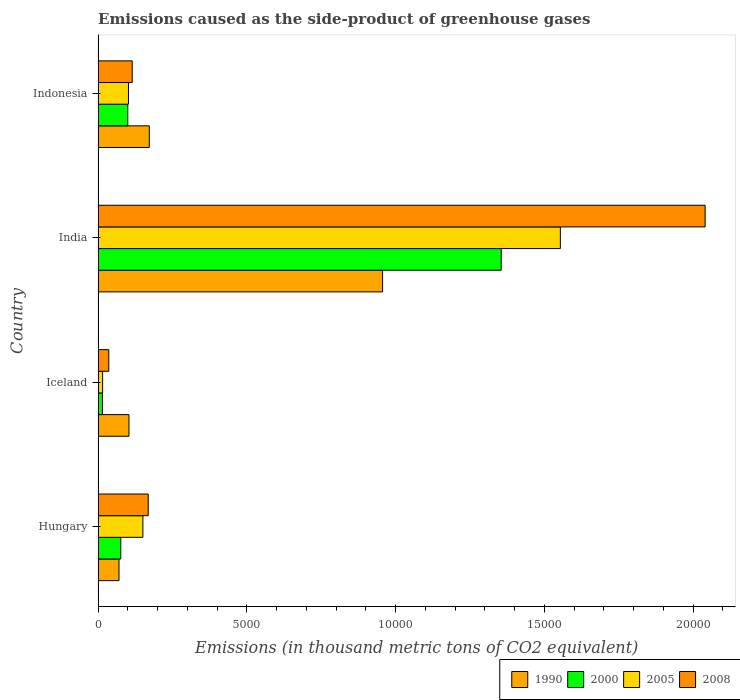Are the number of bars on each tick of the Y-axis equal?
Your answer should be compact. Yes. How many bars are there on the 1st tick from the top?
Ensure brevity in your answer.  4. What is the label of the 2nd group of bars from the top?
Offer a terse response. India. What is the emissions caused as the side-product of greenhouse gases in 1990 in Hungary?
Your answer should be compact. 702. Across all countries, what is the maximum emissions caused as the side-product of greenhouse gases in 1990?
Offer a very short reply. 9563.6. Across all countries, what is the minimum emissions caused as the side-product of greenhouse gases in 2008?
Your answer should be very brief. 358.5. In which country was the emissions caused as the side-product of greenhouse gases in 1990 minimum?
Give a very brief answer. Hungary. What is the total emissions caused as the side-product of greenhouse gases in 2000 in the graph?
Provide a short and direct response. 1.55e+04. What is the difference between the emissions caused as the side-product of greenhouse gases in 1990 in Hungary and that in Indonesia?
Your response must be concise. -1018.7. What is the difference between the emissions caused as the side-product of greenhouse gases in 1990 in Iceland and the emissions caused as the side-product of greenhouse gases in 2008 in Indonesia?
Ensure brevity in your answer.  -109.1. What is the average emissions caused as the side-product of greenhouse gases in 1990 per country?
Give a very brief answer. 3255.8. What is the difference between the emissions caused as the side-product of greenhouse gases in 2000 and emissions caused as the side-product of greenhouse gases in 1990 in Iceland?
Provide a succinct answer. -892.1. In how many countries, is the emissions caused as the side-product of greenhouse gases in 2005 greater than 16000 thousand metric tons?
Your answer should be very brief. 0. What is the ratio of the emissions caused as the side-product of greenhouse gases in 2005 in Hungary to that in India?
Your response must be concise. 0.1. Is the difference between the emissions caused as the side-product of greenhouse gases in 2000 in Iceland and Indonesia greater than the difference between the emissions caused as the side-product of greenhouse gases in 1990 in Iceland and Indonesia?
Give a very brief answer. No. What is the difference between the highest and the second highest emissions caused as the side-product of greenhouse gases in 2008?
Provide a succinct answer. 1.87e+04. What is the difference between the highest and the lowest emissions caused as the side-product of greenhouse gases in 2008?
Ensure brevity in your answer.  2.00e+04. Is it the case that in every country, the sum of the emissions caused as the side-product of greenhouse gases in 2000 and emissions caused as the side-product of greenhouse gases in 2008 is greater than the sum of emissions caused as the side-product of greenhouse gases in 1990 and emissions caused as the side-product of greenhouse gases in 2005?
Your response must be concise. No. What does the 1st bar from the top in India represents?
Your answer should be very brief. 2008. What does the 1st bar from the bottom in Iceland represents?
Your answer should be compact. 1990. Are all the bars in the graph horizontal?
Make the answer very short. Yes. What is the difference between two consecutive major ticks on the X-axis?
Your answer should be compact. 5000. Are the values on the major ticks of X-axis written in scientific E-notation?
Provide a succinct answer. No. Where does the legend appear in the graph?
Provide a succinct answer. Bottom right. How are the legend labels stacked?
Your answer should be compact. Horizontal. What is the title of the graph?
Provide a short and direct response. Emissions caused as the side-product of greenhouse gases. Does "1993" appear as one of the legend labels in the graph?
Provide a short and direct response. No. What is the label or title of the X-axis?
Your answer should be very brief. Emissions (in thousand metric tons of CO2 equivalent). What is the Emissions (in thousand metric tons of CO2 equivalent) of 1990 in Hungary?
Provide a short and direct response. 702. What is the Emissions (in thousand metric tons of CO2 equivalent) in 2000 in Hungary?
Provide a short and direct response. 761.9. What is the Emissions (in thousand metric tons of CO2 equivalent) of 2005 in Hungary?
Your response must be concise. 1505.1. What is the Emissions (in thousand metric tons of CO2 equivalent) of 2008 in Hungary?
Your response must be concise. 1684.5. What is the Emissions (in thousand metric tons of CO2 equivalent) of 1990 in Iceland?
Your response must be concise. 1036.9. What is the Emissions (in thousand metric tons of CO2 equivalent) of 2000 in Iceland?
Give a very brief answer. 144.8. What is the Emissions (in thousand metric tons of CO2 equivalent) of 2005 in Iceland?
Make the answer very short. 151.7. What is the Emissions (in thousand metric tons of CO2 equivalent) in 2008 in Iceland?
Keep it short and to the point. 358.5. What is the Emissions (in thousand metric tons of CO2 equivalent) of 1990 in India?
Offer a very short reply. 9563.6. What is the Emissions (in thousand metric tons of CO2 equivalent) in 2000 in India?
Your answer should be compact. 1.36e+04. What is the Emissions (in thousand metric tons of CO2 equivalent) of 2005 in India?
Make the answer very short. 1.55e+04. What is the Emissions (in thousand metric tons of CO2 equivalent) in 2008 in India?
Offer a terse response. 2.04e+04. What is the Emissions (in thousand metric tons of CO2 equivalent) of 1990 in Indonesia?
Ensure brevity in your answer.  1720.7. What is the Emissions (in thousand metric tons of CO2 equivalent) of 2000 in Indonesia?
Your answer should be very brief. 997.4. What is the Emissions (in thousand metric tons of CO2 equivalent) in 2005 in Indonesia?
Your response must be concise. 1020.5. What is the Emissions (in thousand metric tons of CO2 equivalent) in 2008 in Indonesia?
Give a very brief answer. 1146. Across all countries, what is the maximum Emissions (in thousand metric tons of CO2 equivalent) in 1990?
Offer a terse response. 9563.6. Across all countries, what is the maximum Emissions (in thousand metric tons of CO2 equivalent) of 2000?
Offer a very short reply. 1.36e+04. Across all countries, what is the maximum Emissions (in thousand metric tons of CO2 equivalent) in 2005?
Keep it short and to the point. 1.55e+04. Across all countries, what is the maximum Emissions (in thousand metric tons of CO2 equivalent) of 2008?
Make the answer very short. 2.04e+04. Across all countries, what is the minimum Emissions (in thousand metric tons of CO2 equivalent) in 1990?
Provide a succinct answer. 702. Across all countries, what is the minimum Emissions (in thousand metric tons of CO2 equivalent) in 2000?
Provide a short and direct response. 144.8. Across all countries, what is the minimum Emissions (in thousand metric tons of CO2 equivalent) of 2005?
Offer a very short reply. 151.7. Across all countries, what is the minimum Emissions (in thousand metric tons of CO2 equivalent) of 2008?
Provide a succinct answer. 358.5. What is the total Emissions (in thousand metric tons of CO2 equivalent) of 1990 in the graph?
Keep it short and to the point. 1.30e+04. What is the total Emissions (in thousand metric tons of CO2 equivalent) in 2000 in the graph?
Give a very brief answer. 1.55e+04. What is the total Emissions (in thousand metric tons of CO2 equivalent) in 2005 in the graph?
Offer a very short reply. 1.82e+04. What is the total Emissions (in thousand metric tons of CO2 equivalent) in 2008 in the graph?
Provide a short and direct response. 2.36e+04. What is the difference between the Emissions (in thousand metric tons of CO2 equivalent) in 1990 in Hungary and that in Iceland?
Ensure brevity in your answer.  -334.9. What is the difference between the Emissions (in thousand metric tons of CO2 equivalent) in 2000 in Hungary and that in Iceland?
Provide a succinct answer. 617.1. What is the difference between the Emissions (in thousand metric tons of CO2 equivalent) in 2005 in Hungary and that in Iceland?
Your response must be concise. 1353.4. What is the difference between the Emissions (in thousand metric tons of CO2 equivalent) in 2008 in Hungary and that in Iceland?
Provide a succinct answer. 1326. What is the difference between the Emissions (in thousand metric tons of CO2 equivalent) in 1990 in Hungary and that in India?
Offer a very short reply. -8861.6. What is the difference between the Emissions (in thousand metric tons of CO2 equivalent) in 2000 in Hungary and that in India?
Keep it short and to the point. -1.28e+04. What is the difference between the Emissions (in thousand metric tons of CO2 equivalent) in 2005 in Hungary and that in India?
Provide a short and direct response. -1.40e+04. What is the difference between the Emissions (in thousand metric tons of CO2 equivalent) of 2008 in Hungary and that in India?
Provide a succinct answer. -1.87e+04. What is the difference between the Emissions (in thousand metric tons of CO2 equivalent) of 1990 in Hungary and that in Indonesia?
Offer a terse response. -1018.7. What is the difference between the Emissions (in thousand metric tons of CO2 equivalent) in 2000 in Hungary and that in Indonesia?
Provide a succinct answer. -235.5. What is the difference between the Emissions (in thousand metric tons of CO2 equivalent) of 2005 in Hungary and that in Indonesia?
Offer a terse response. 484.6. What is the difference between the Emissions (in thousand metric tons of CO2 equivalent) of 2008 in Hungary and that in Indonesia?
Your answer should be compact. 538.5. What is the difference between the Emissions (in thousand metric tons of CO2 equivalent) in 1990 in Iceland and that in India?
Give a very brief answer. -8526.7. What is the difference between the Emissions (in thousand metric tons of CO2 equivalent) of 2000 in Iceland and that in India?
Give a very brief answer. -1.34e+04. What is the difference between the Emissions (in thousand metric tons of CO2 equivalent) of 2005 in Iceland and that in India?
Your response must be concise. -1.54e+04. What is the difference between the Emissions (in thousand metric tons of CO2 equivalent) of 2008 in Iceland and that in India?
Your answer should be very brief. -2.00e+04. What is the difference between the Emissions (in thousand metric tons of CO2 equivalent) in 1990 in Iceland and that in Indonesia?
Ensure brevity in your answer.  -683.8. What is the difference between the Emissions (in thousand metric tons of CO2 equivalent) of 2000 in Iceland and that in Indonesia?
Offer a terse response. -852.6. What is the difference between the Emissions (in thousand metric tons of CO2 equivalent) in 2005 in Iceland and that in Indonesia?
Provide a short and direct response. -868.8. What is the difference between the Emissions (in thousand metric tons of CO2 equivalent) of 2008 in Iceland and that in Indonesia?
Offer a very short reply. -787.5. What is the difference between the Emissions (in thousand metric tons of CO2 equivalent) in 1990 in India and that in Indonesia?
Your answer should be very brief. 7842.9. What is the difference between the Emissions (in thousand metric tons of CO2 equivalent) of 2000 in India and that in Indonesia?
Offer a very short reply. 1.26e+04. What is the difference between the Emissions (in thousand metric tons of CO2 equivalent) of 2005 in India and that in Indonesia?
Ensure brevity in your answer.  1.45e+04. What is the difference between the Emissions (in thousand metric tons of CO2 equivalent) of 2008 in India and that in Indonesia?
Ensure brevity in your answer.  1.93e+04. What is the difference between the Emissions (in thousand metric tons of CO2 equivalent) of 1990 in Hungary and the Emissions (in thousand metric tons of CO2 equivalent) of 2000 in Iceland?
Keep it short and to the point. 557.2. What is the difference between the Emissions (in thousand metric tons of CO2 equivalent) in 1990 in Hungary and the Emissions (in thousand metric tons of CO2 equivalent) in 2005 in Iceland?
Your answer should be very brief. 550.3. What is the difference between the Emissions (in thousand metric tons of CO2 equivalent) in 1990 in Hungary and the Emissions (in thousand metric tons of CO2 equivalent) in 2008 in Iceland?
Keep it short and to the point. 343.5. What is the difference between the Emissions (in thousand metric tons of CO2 equivalent) of 2000 in Hungary and the Emissions (in thousand metric tons of CO2 equivalent) of 2005 in Iceland?
Your answer should be very brief. 610.2. What is the difference between the Emissions (in thousand metric tons of CO2 equivalent) of 2000 in Hungary and the Emissions (in thousand metric tons of CO2 equivalent) of 2008 in Iceland?
Make the answer very short. 403.4. What is the difference between the Emissions (in thousand metric tons of CO2 equivalent) in 2005 in Hungary and the Emissions (in thousand metric tons of CO2 equivalent) in 2008 in Iceland?
Ensure brevity in your answer.  1146.6. What is the difference between the Emissions (in thousand metric tons of CO2 equivalent) of 1990 in Hungary and the Emissions (in thousand metric tons of CO2 equivalent) of 2000 in India?
Provide a succinct answer. -1.28e+04. What is the difference between the Emissions (in thousand metric tons of CO2 equivalent) in 1990 in Hungary and the Emissions (in thousand metric tons of CO2 equivalent) in 2005 in India?
Keep it short and to the point. -1.48e+04. What is the difference between the Emissions (in thousand metric tons of CO2 equivalent) of 1990 in Hungary and the Emissions (in thousand metric tons of CO2 equivalent) of 2008 in India?
Your response must be concise. -1.97e+04. What is the difference between the Emissions (in thousand metric tons of CO2 equivalent) of 2000 in Hungary and the Emissions (in thousand metric tons of CO2 equivalent) of 2005 in India?
Your answer should be compact. -1.48e+04. What is the difference between the Emissions (in thousand metric tons of CO2 equivalent) in 2000 in Hungary and the Emissions (in thousand metric tons of CO2 equivalent) in 2008 in India?
Your response must be concise. -1.96e+04. What is the difference between the Emissions (in thousand metric tons of CO2 equivalent) in 2005 in Hungary and the Emissions (in thousand metric tons of CO2 equivalent) in 2008 in India?
Keep it short and to the point. -1.89e+04. What is the difference between the Emissions (in thousand metric tons of CO2 equivalent) in 1990 in Hungary and the Emissions (in thousand metric tons of CO2 equivalent) in 2000 in Indonesia?
Offer a very short reply. -295.4. What is the difference between the Emissions (in thousand metric tons of CO2 equivalent) in 1990 in Hungary and the Emissions (in thousand metric tons of CO2 equivalent) in 2005 in Indonesia?
Keep it short and to the point. -318.5. What is the difference between the Emissions (in thousand metric tons of CO2 equivalent) of 1990 in Hungary and the Emissions (in thousand metric tons of CO2 equivalent) of 2008 in Indonesia?
Provide a short and direct response. -444. What is the difference between the Emissions (in thousand metric tons of CO2 equivalent) in 2000 in Hungary and the Emissions (in thousand metric tons of CO2 equivalent) in 2005 in Indonesia?
Provide a short and direct response. -258.6. What is the difference between the Emissions (in thousand metric tons of CO2 equivalent) in 2000 in Hungary and the Emissions (in thousand metric tons of CO2 equivalent) in 2008 in Indonesia?
Provide a succinct answer. -384.1. What is the difference between the Emissions (in thousand metric tons of CO2 equivalent) in 2005 in Hungary and the Emissions (in thousand metric tons of CO2 equivalent) in 2008 in Indonesia?
Make the answer very short. 359.1. What is the difference between the Emissions (in thousand metric tons of CO2 equivalent) in 1990 in Iceland and the Emissions (in thousand metric tons of CO2 equivalent) in 2000 in India?
Provide a succinct answer. -1.25e+04. What is the difference between the Emissions (in thousand metric tons of CO2 equivalent) of 1990 in Iceland and the Emissions (in thousand metric tons of CO2 equivalent) of 2005 in India?
Your answer should be very brief. -1.45e+04. What is the difference between the Emissions (in thousand metric tons of CO2 equivalent) of 1990 in Iceland and the Emissions (in thousand metric tons of CO2 equivalent) of 2008 in India?
Your answer should be very brief. -1.94e+04. What is the difference between the Emissions (in thousand metric tons of CO2 equivalent) of 2000 in Iceland and the Emissions (in thousand metric tons of CO2 equivalent) of 2005 in India?
Your answer should be very brief. -1.54e+04. What is the difference between the Emissions (in thousand metric tons of CO2 equivalent) in 2000 in Iceland and the Emissions (in thousand metric tons of CO2 equivalent) in 2008 in India?
Give a very brief answer. -2.03e+04. What is the difference between the Emissions (in thousand metric tons of CO2 equivalent) of 2005 in Iceland and the Emissions (in thousand metric tons of CO2 equivalent) of 2008 in India?
Ensure brevity in your answer.  -2.03e+04. What is the difference between the Emissions (in thousand metric tons of CO2 equivalent) in 1990 in Iceland and the Emissions (in thousand metric tons of CO2 equivalent) in 2000 in Indonesia?
Give a very brief answer. 39.5. What is the difference between the Emissions (in thousand metric tons of CO2 equivalent) in 1990 in Iceland and the Emissions (in thousand metric tons of CO2 equivalent) in 2008 in Indonesia?
Your response must be concise. -109.1. What is the difference between the Emissions (in thousand metric tons of CO2 equivalent) in 2000 in Iceland and the Emissions (in thousand metric tons of CO2 equivalent) in 2005 in Indonesia?
Your answer should be compact. -875.7. What is the difference between the Emissions (in thousand metric tons of CO2 equivalent) of 2000 in Iceland and the Emissions (in thousand metric tons of CO2 equivalent) of 2008 in Indonesia?
Your answer should be very brief. -1001.2. What is the difference between the Emissions (in thousand metric tons of CO2 equivalent) of 2005 in Iceland and the Emissions (in thousand metric tons of CO2 equivalent) of 2008 in Indonesia?
Keep it short and to the point. -994.3. What is the difference between the Emissions (in thousand metric tons of CO2 equivalent) in 1990 in India and the Emissions (in thousand metric tons of CO2 equivalent) in 2000 in Indonesia?
Give a very brief answer. 8566.2. What is the difference between the Emissions (in thousand metric tons of CO2 equivalent) of 1990 in India and the Emissions (in thousand metric tons of CO2 equivalent) of 2005 in Indonesia?
Keep it short and to the point. 8543.1. What is the difference between the Emissions (in thousand metric tons of CO2 equivalent) of 1990 in India and the Emissions (in thousand metric tons of CO2 equivalent) of 2008 in Indonesia?
Your response must be concise. 8417.6. What is the difference between the Emissions (in thousand metric tons of CO2 equivalent) in 2000 in India and the Emissions (in thousand metric tons of CO2 equivalent) in 2005 in Indonesia?
Provide a succinct answer. 1.25e+04. What is the difference between the Emissions (in thousand metric tons of CO2 equivalent) of 2000 in India and the Emissions (in thousand metric tons of CO2 equivalent) of 2008 in Indonesia?
Give a very brief answer. 1.24e+04. What is the difference between the Emissions (in thousand metric tons of CO2 equivalent) in 2005 in India and the Emissions (in thousand metric tons of CO2 equivalent) in 2008 in Indonesia?
Make the answer very short. 1.44e+04. What is the average Emissions (in thousand metric tons of CO2 equivalent) in 1990 per country?
Offer a very short reply. 3255.8. What is the average Emissions (in thousand metric tons of CO2 equivalent) of 2000 per country?
Provide a succinct answer. 3863.7. What is the average Emissions (in thousand metric tons of CO2 equivalent) of 2005 per country?
Offer a very short reply. 4554.25. What is the average Emissions (in thousand metric tons of CO2 equivalent) of 2008 per country?
Offer a very short reply. 5898.98. What is the difference between the Emissions (in thousand metric tons of CO2 equivalent) in 1990 and Emissions (in thousand metric tons of CO2 equivalent) in 2000 in Hungary?
Give a very brief answer. -59.9. What is the difference between the Emissions (in thousand metric tons of CO2 equivalent) of 1990 and Emissions (in thousand metric tons of CO2 equivalent) of 2005 in Hungary?
Your response must be concise. -803.1. What is the difference between the Emissions (in thousand metric tons of CO2 equivalent) in 1990 and Emissions (in thousand metric tons of CO2 equivalent) in 2008 in Hungary?
Provide a succinct answer. -982.5. What is the difference between the Emissions (in thousand metric tons of CO2 equivalent) of 2000 and Emissions (in thousand metric tons of CO2 equivalent) of 2005 in Hungary?
Keep it short and to the point. -743.2. What is the difference between the Emissions (in thousand metric tons of CO2 equivalent) in 2000 and Emissions (in thousand metric tons of CO2 equivalent) in 2008 in Hungary?
Your response must be concise. -922.6. What is the difference between the Emissions (in thousand metric tons of CO2 equivalent) in 2005 and Emissions (in thousand metric tons of CO2 equivalent) in 2008 in Hungary?
Offer a very short reply. -179.4. What is the difference between the Emissions (in thousand metric tons of CO2 equivalent) in 1990 and Emissions (in thousand metric tons of CO2 equivalent) in 2000 in Iceland?
Ensure brevity in your answer.  892.1. What is the difference between the Emissions (in thousand metric tons of CO2 equivalent) in 1990 and Emissions (in thousand metric tons of CO2 equivalent) in 2005 in Iceland?
Your response must be concise. 885.2. What is the difference between the Emissions (in thousand metric tons of CO2 equivalent) in 1990 and Emissions (in thousand metric tons of CO2 equivalent) in 2008 in Iceland?
Provide a short and direct response. 678.4. What is the difference between the Emissions (in thousand metric tons of CO2 equivalent) in 2000 and Emissions (in thousand metric tons of CO2 equivalent) in 2005 in Iceland?
Your answer should be compact. -6.9. What is the difference between the Emissions (in thousand metric tons of CO2 equivalent) in 2000 and Emissions (in thousand metric tons of CO2 equivalent) in 2008 in Iceland?
Provide a short and direct response. -213.7. What is the difference between the Emissions (in thousand metric tons of CO2 equivalent) of 2005 and Emissions (in thousand metric tons of CO2 equivalent) of 2008 in Iceland?
Keep it short and to the point. -206.8. What is the difference between the Emissions (in thousand metric tons of CO2 equivalent) of 1990 and Emissions (in thousand metric tons of CO2 equivalent) of 2000 in India?
Offer a terse response. -3987.1. What is the difference between the Emissions (in thousand metric tons of CO2 equivalent) of 1990 and Emissions (in thousand metric tons of CO2 equivalent) of 2005 in India?
Make the answer very short. -5976.1. What is the difference between the Emissions (in thousand metric tons of CO2 equivalent) of 1990 and Emissions (in thousand metric tons of CO2 equivalent) of 2008 in India?
Your answer should be very brief. -1.08e+04. What is the difference between the Emissions (in thousand metric tons of CO2 equivalent) in 2000 and Emissions (in thousand metric tons of CO2 equivalent) in 2005 in India?
Give a very brief answer. -1989. What is the difference between the Emissions (in thousand metric tons of CO2 equivalent) in 2000 and Emissions (in thousand metric tons of CO2 equivalent) in 2008 in India?
Make the answer very short. -6856.2. What is the difference between the Emissions (in thousand metric tons of CO2 equivalent) of 2005 and Emissions (in thousand metric tons of CO2 equivalent) of 2008 in India?
Offer a very short reply. -4867.2. What is the difference between the Emissions (in thousand metric tons of CO2 equivalent) in 1990 and Emissions (in thousand metric tons of CO2 equivalent) in 2000 in Indonesia?
Your answer should be compact. 723.3. What is the difference between the Emissions (in thousand metric tons of CO2 equivalent) of 1990 and Emissions (in thousand metric tons of CO2 equivalent) of 2005 in Indonesia?
Keep it short and to the point. 700.2. What is the difference between the Emissions (in thousand metric tons of CO2 equivalent) in 1990 and Emissions (in thousand metric tons of CO2 equivalent) in 2008 in Indonesia?
Offer a terse response. 574.7. What is the difference between the Emissions (in thousand metric tons of CO2 equivalent) of 2000 and Emissions (in thousand metric tons of CO2 equivalent) of 2005 in Indonesia?
Keep it short and to the point. -23.1. What is the difference between the Emissions (in thousand metric tons of CO2 equivalent) of 2000 and Emissions (in thousand metric tons of CO2 equivalent) of 2008 in Indonesia?
Give a very brief answer. -148.6. What is the difference between the Emissions (in thousand metric tons of CO2 equivalent) of 2005 and Emissions (in thousand metric tons of CO2 equivalent) of 2008 in Indonesia?
Your response must be concise. -125.5. What is the ratio of the Emissions (in thousand metric tons of CO2 equivalent) of 1990 in Hungary to that in Iceland?
Make the answer very short. 0.68. What is the ratio of the Emissions (in thousand metric tons of CO2 equivalent) of 2000 in Hungary to that in Iceland?
Your answer should be very brief. 5.26. What is the ratio of the Emissions (in thousand metric tons of CO2 equivalent) of 2005 in Hungary to that in Iceland?
Ensure brevity in your answer.  9.92. What is the ratio of the Emissions (in thousand metric tons of CO2 equivalent) of 2008 in Hungary to that in Iceland?
Make the answer very short. 4.7. What is the ratio of the Emissions (in thousand metric tons of CO2 equivalent) in 1990 in Hungary to that in India?
Keep it short and to the point. 0.07. What is the ratio of the Emissions (in thousand metric tons of CO2 equivalent) in 2000 in Hungary to that in India?
Give a very brief answer. 0.06. What is the ratio of the Emissions (in thousand metric tons of CO2 equivalent) of 2005 in Hungary to that in India?
Keep it short and to the point. 0.1. What is the ratio of the Emissions (in thousand metric tons of CO2 equivalent) in 2008 in Hungary to that in India?
Your response must be concise. 0.08. What is the ratio of the Emissions (in thousand metric tons of CO2 equivalent) of 1990 in Hungary to that in Indonesia?
Provide a succinct answer. 0.41. What is the ratio of the Emissions (in thousand metric tons of CO2 equivalent) of 2000 in Hungary to that in Indonesia?
Give a very brief answer. 0.76. What is the ratio of the Emissions (in thousand metric tons of CO2 equivalent) in 2005 in Hungary to that in Indonesia?
Make the answer very short. 1.47. What is the ratio of the Emissions (in thousand metric tons of CO2 equivalent) of 2008 in Hungary to that in Indonesia?
Make the answer very short. 1.47. What is the ratio of the Emissions (in thousand metric tons of CO2 equivalent) of 1990 in Iceland to that in India?
Give a very brief answer. 0.11. What is the ratio of the Emissions (in thousand metric tons of CO2 equivalent) of 2000 in Iceland to that in India?
Offer a very short reply. 0.01. What is the ratio of the Emissions (in thousand metric tons of CO2 equivalent) in 2005 in Iceland to that in India?
Your answer should be compact. 0.01. What is the ratio of the Emissions (in thousand metric tons of CO2 equivalent) of 2008 in Iceland to that in India?
Give a very brief answer. 0.02. What is the ratio of the Emissions (in thousand metric tons of CO2 equivalent) in 1990 in Iceland to that in Indonesia?
Give a very brief answer. 0.6. What is the ratio of the Emissions (in thousand metric tons of CO2 equivalent) in 2000 in Iceland to that in Indonesia?
Provide a succinct answer. 0.15. What is the ratio of the Emissions (in thousand metric tons of CO2 equivalent) in 2005 in Iceland to that in Indonesia?
Provide a short and direct response. 0.15. What is the ratio of the Emissions (in thousand metric tons of CO2 equivalent) of 2008 in Iceland to that in Indonesia?
Your answer should be very brief. 0.31. What is the ratio of the Emissions (in thousand metric tons of CO2 equivalent) of 1990 in India to that in Indonesia?
Offer a very short reply. 5.56. What is the ratio of the Emissions (in thousand metric tons of CO2 equivalent) in 2000 in India to that in Indonesia?
Ensure brevity in your answer.  13.59. What is the ratio of the Emissions (in thousand metric tons of CO2 equivalent) in 2005 in India to that in Indonesia?
Give a very brief answer. 15.23. What is the ratio of the Emissions (in thousand metric tons of CO2 equivalent) in 2008 in India to that in Indonesia?
Ensure brevity in your answer.  17.81. What is the difference between the highest and the second highest Emissions (in thousand metric tons of CO2 equivalent) in 1990?
Provide a succinct answer. 7842.9. What is the difference between the highest and the second highest Emissions (in thousand metric tons of CO2 equivalent) of 2000?
Offer a very short reply. 1.26e+04. What is the difference between the highest and the second highest Emissions (in thousand metric tons of CO2 equivalent) in 2005?
Make the answer very short. 1.40e+04. What is the difference between the highest and the second highest Emissions (in thousand metric tons of CO2 equivalent) in 2008?
Make the answer very short. 1.87e+04. What is the difference between the highest and the lowest Emissions (in thousand metric tons of CO2 equivalent) of 1990?
Your response must be concise. 8861.6. What is the difference between the highest and the lowest Emissions (in thousand metric tons of CO2 equivalent) of 2000?
Your answer should be compact. 1.34e+04. What is the difference between the highest and the lowest Emissions (in thousand metric tons of CO2 equivalent) in 2005?
Offer a very short reply. 1.54e+04. What is the difference between the highest and the lowest Emissions (in thousand metric tons of CO2 equivalent) in 2008?
Make the answer very short. 2.00e+04. 